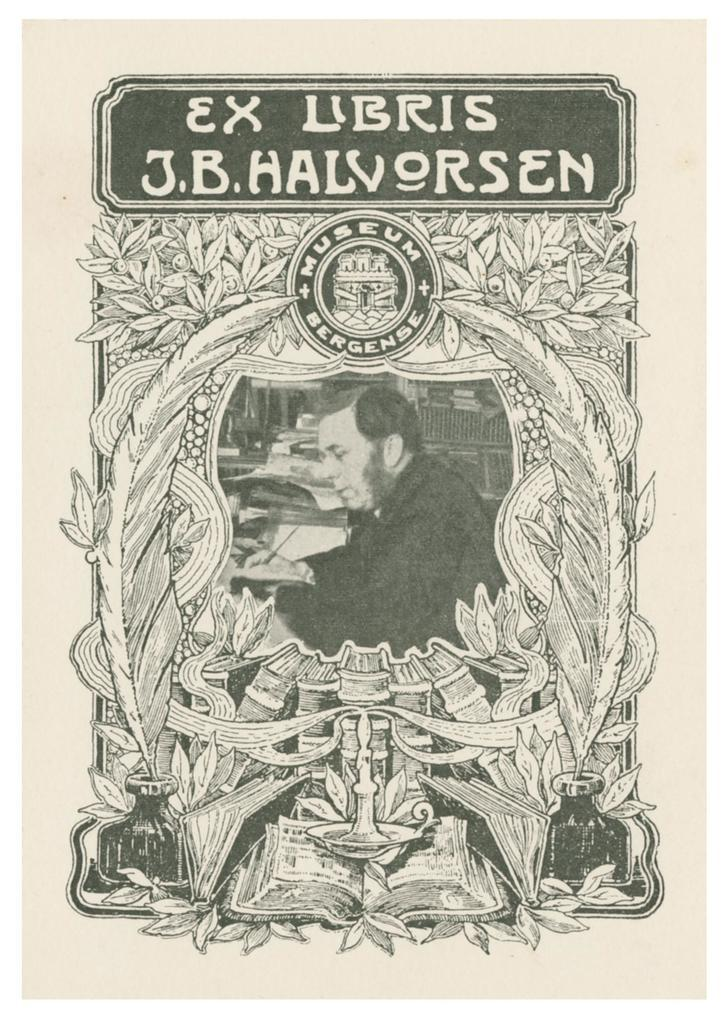<image>
Describe the image concisely. A black and white museum poster contains the name J.B. Halvorsen near the top. 